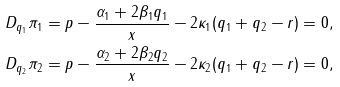Convert formula to latex. <formula><loc_0><loc_0><loc_500><loc_500>D _ { q _ { 1 } } \pi _ { 1 } = p - \frac { \alpha _ { 1 } + 2 \beta _ { 1 } q _ { 1 } } { x } - 2 \kappa _ { 1 } ( q _ { 1 } + q _ { 2 } - r ) & = 0 , \\ D _ { q _ { 2 } } \pi _ { 2 } = p - \frac { \alpha _ { 2 } + 2 \beta _ { 2 } q _ { 2 } } { x } - 2 \kappa _ { 2 } ( q _ { 1 } + q _ { 2 } - r ) & = 0 , \\</formula> 